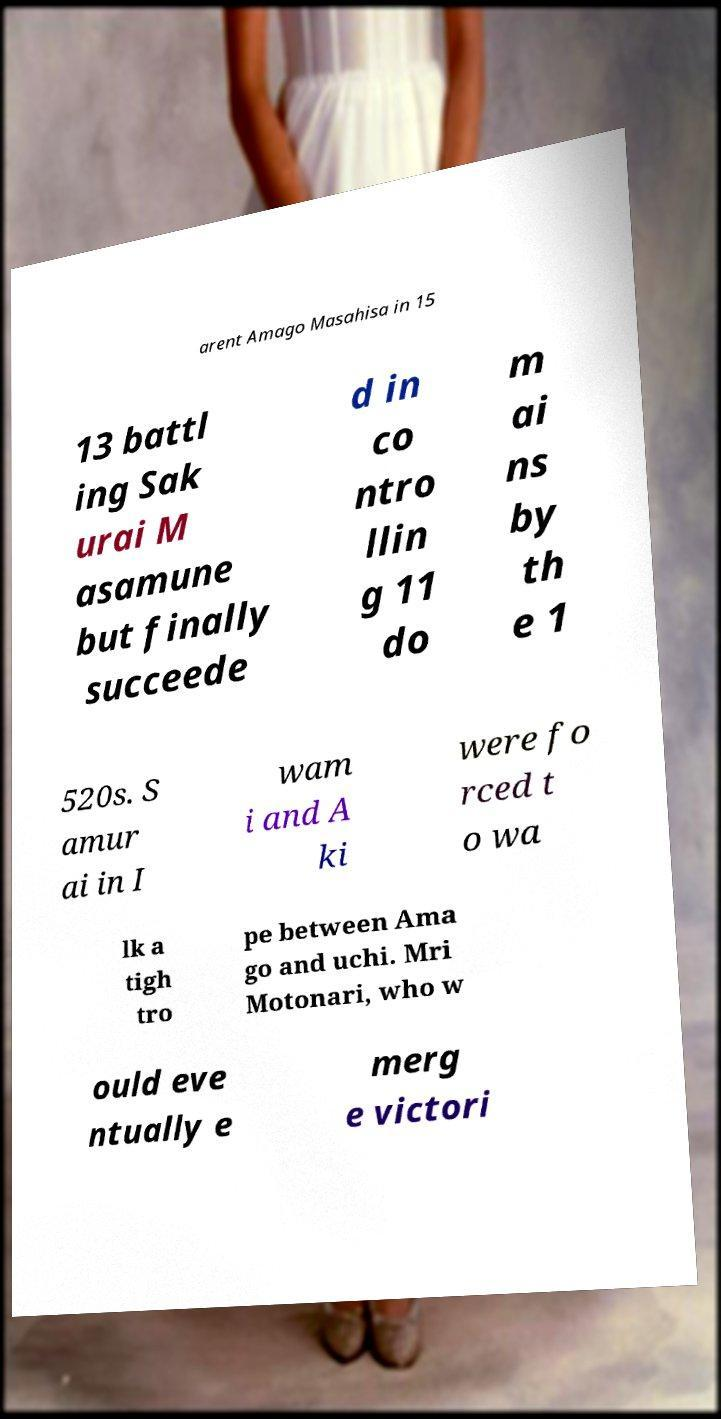Please identify and transcribe the text found in this image. arent Amago Masahisa in 15 13 battl ing Sak urai M asamune but finally succeede d in co ntro llin g 11 do m ai ns by th e 1 520s. S amur ai in I wam i and A ki were fo rced t o wa lk a tigh tro pe between Ama go and uchi. Mri Motonari, who w ould eve ntually e merg e victori 